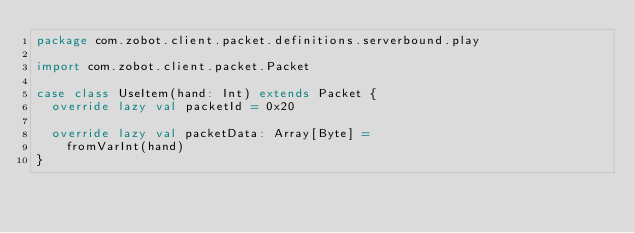Convert code to text. <code><loc_0><loc_0><loc_500><loc_500><_Scala_>package com.zobot.client.packet.definitions.serverbound.play

import com.zobot.client.packet.Packet

case class UseItem(hand: Int) extends Packet {
  override lazy val packetId = 0x20

  override lazy val packetData: Array[Byte] =
    fromVarInt(hand)
}
</code> 